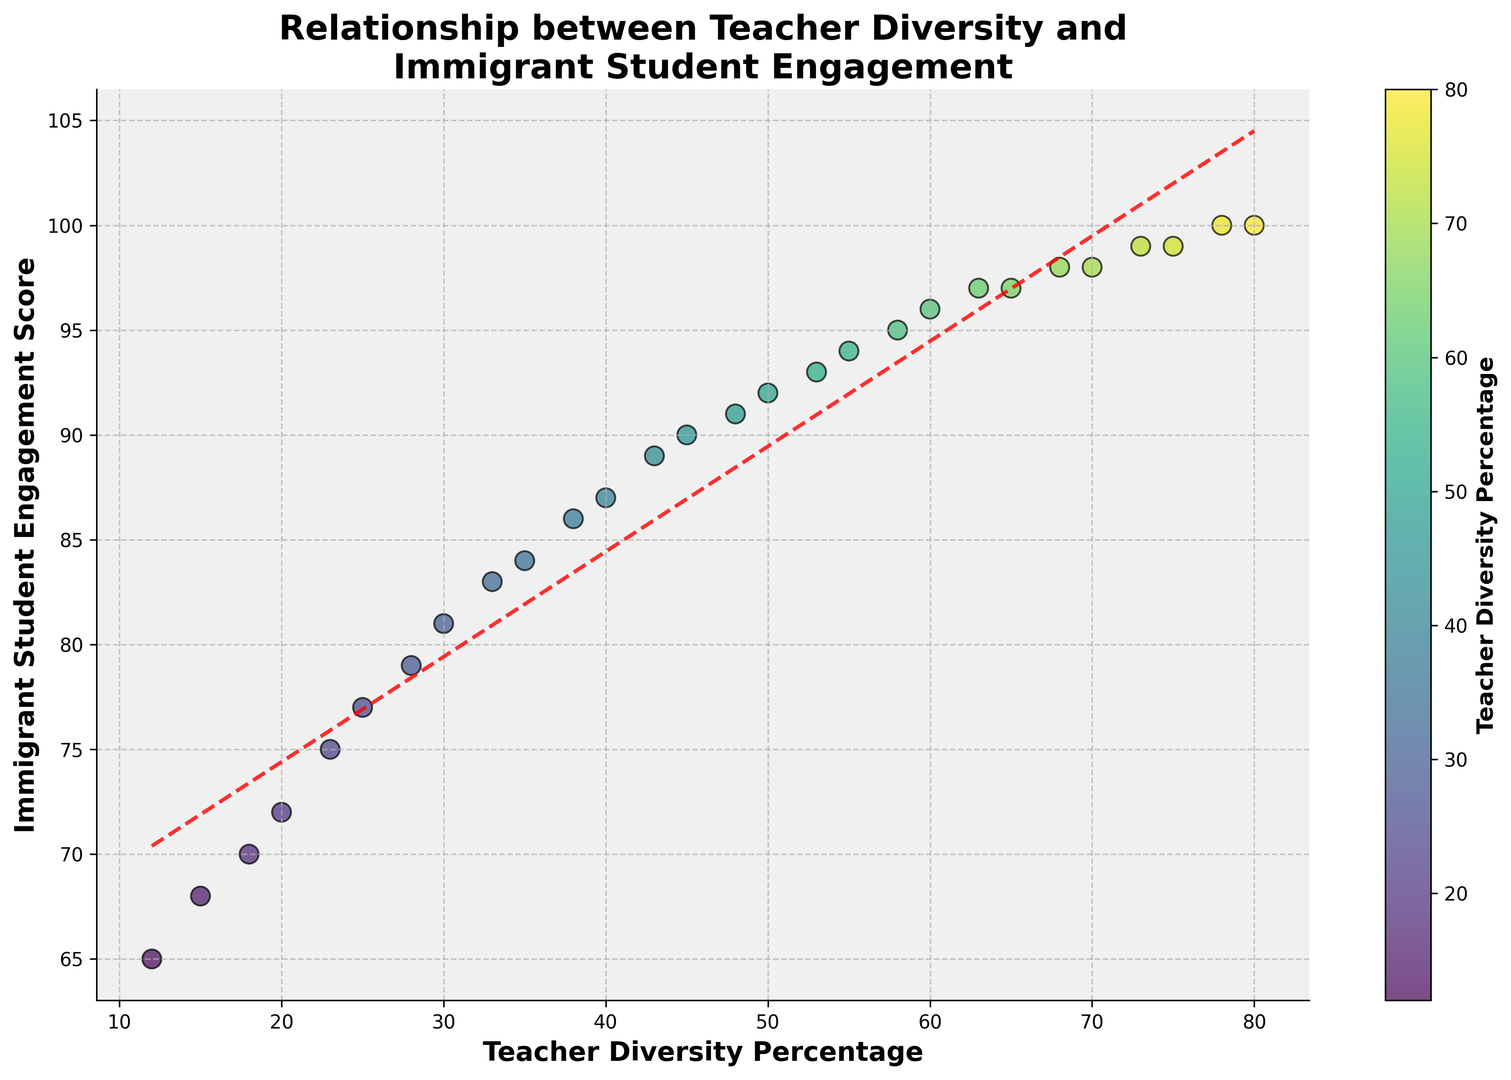What's the overall trend shown in the scatter plot? The scatter plot shows an upward trend. As the Teacher Diversity Percentage increases, the Immigrant Student Engagement Score also increases. This relationship is highlighted by the red dashed line, which represents a positive linear fit.
Answer: Positive correlation Does the scatter plot indicate a strong or weak relationship between teacher diversity and immigrant student engagement? The scatter plot indicates a strong relationship. The data points closely follow the red dashed line, which signifies a strong positive linear correlation between Teacher Diversity Percentage and Immigrant Student Engagement Score.
Answer: Strong relationship What is the Teacher Diversity Percentage at which Immigrant Student Engagement Score reaches 75? By looking at the scatter plot, an Immigrant Student Engagement Score of 75 corresponds to a Teacher Diversity Percentage of approximately 23%. This can be seen by finding the point on the y-axis at 75 and drawing a horizontal line to intersect with the scatter points.
Answer: 23% Between Teacher Diversity Percentages of 25% and 50%, which has the higher Immigrant Student Engagement Score, and by how much? At 25%, the Immigrant Student Engagement Score is 77. At 50%, it is 92. So, the score at 50% is higher. The difference is calculated as 92 - 77 = 15.
Answer: 50%, by 15 At what range of Teacher Diversity Percentage do Immigrant Student Engagement Scores plateau, if any? The scatter plot shows that Immigrant Student Engagement Scores start to plateau between Teacher Diversity Percentages of 65% and 80%, where the scores are around 97 to 100. This can be observed by noting the scores do not increase significantly within this range.
Answer: 65% to 80% How does the color intensity change across different Teacher Diversity Percentages? The color intensity varies from lighter to darker as the Teacher Diversity Percentage increases. Data points representing lower percentages are lighter in color, while those representing higher percentages are darker. This is indicated by the scatter plot's color gradient, which corresponds with the color bar on the side.
Answer: Darkens with higher percentages What is the Immigrant Student Engagement Score when Teacher Diversity Percentage is highest? The highest Teacher Diversity Percentage in the scatter plot is 80%. At this percentage, the Immigrant Student Engagement Score is 100. This is obtained by locating the highest x-value and reading off the corresponding y-value.
Answer: 100 Are there any Teacher Diversity Percentages where Immigrant Student Engagement Score is 100? Yes, Immigrant Student Engagement Score reaches 100 at Teacher Diversity Percentages of 78% and 80%. This is identified by finding the y-value of 100 and observing its corresponding x-values on the scatter plot.
Answer: 78% and 80% 